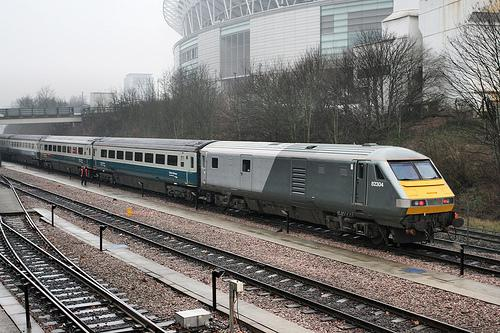Question: when was this picture taken?
Choices:
A. Yesterday.
B. Today.
C. Monday.
D. Tuesday.
Answer with the letter. Answer: A Question: what is on top of the hill?
Choices:
A. Building.
B. House.
C. Castle.
D. School.
Answer with the letter. Answer: A Question: what color is the front of the train?
Choices:
A. Yellow.
B. Red.
C. Blue.
D. Black.
Answer with the letter. Answer: A Question: what is in on the sides of the track?
Choices:
A. Gravel.
B. Rock.
C. Stone.
D. Sand.
Answer with the letter. Answer: A 